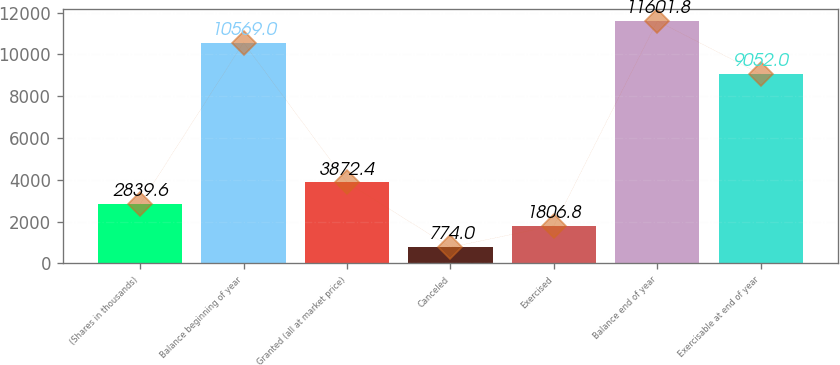Convert chart. <chart><loc_0><loc_0><loc_500><loc_500><bar_chart><fcel>(Shares in thousands)<fcel>Balance beginning of year<fcel>Granted (all at market price)<fcel>Canceled<fcel>Exercised<fcel>Balance end of year<fcel>Exercisable at end of year<nl><fcel>2839.6<fcel>10569<fcel>3872.4<fcel>774<fcel>1806.8<fcel>11601.8<fcel>9052<nl></chart> 